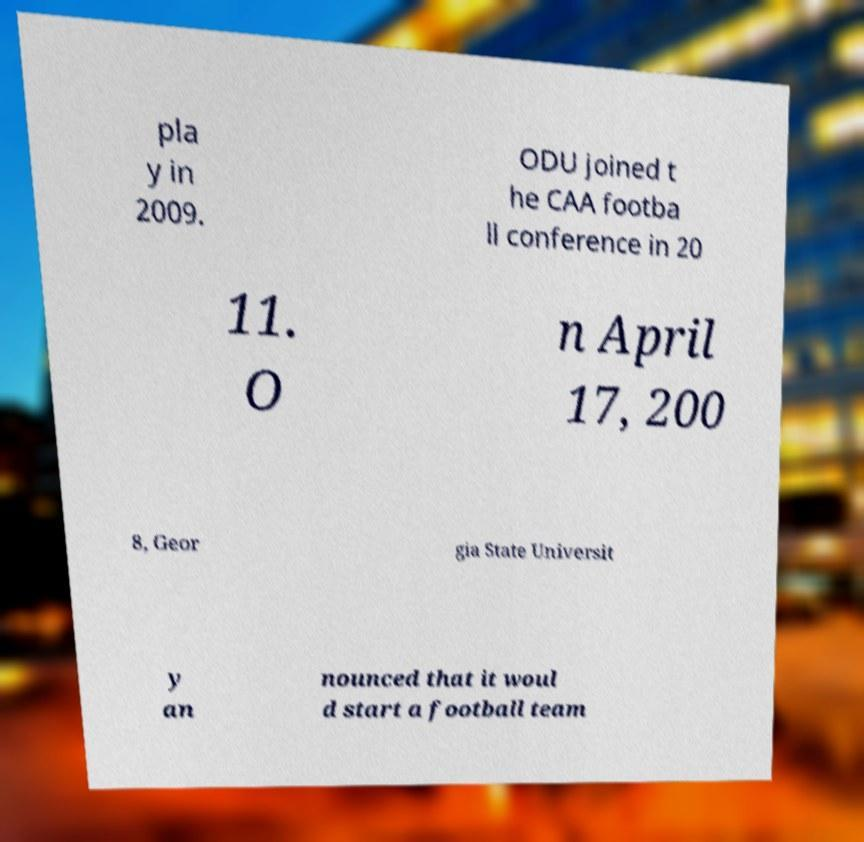Could you assist in decoding the text presented in this image and type it out clearly? pla y in 2009. ODU joined t he CAA footba ll conference in 20 11. O n April 17, 200 8, Geor gia State Universit y an nounced that it woul d start a football team 